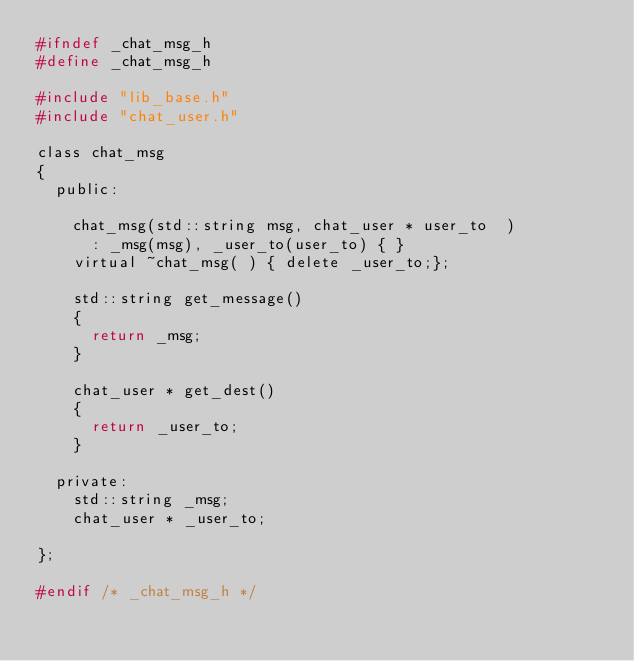<code> <loc_0><loc_0><loc_500><loc_500><_C_>#ifndef _chat_msg_h
#define _chat_msg_h

#include "lib_base.h"
#include "chat_user.h"

class chat_msg
{
  public:

    chat_msg(std::string msg, chat_user * user_to  )
      : _msg(msg), _user_to(user_to) { }
    virtual ~chat_msg( ) { delete _user_to;};

    std::string get_message()
    {
      return _msg;
    }

    chat_user * get_dest()
    {
      return _user_to;
    }

  private:
    std::string _msg;
    chat_user * _user_to;

};

#endif /* _chat_msg_h */
</code> 